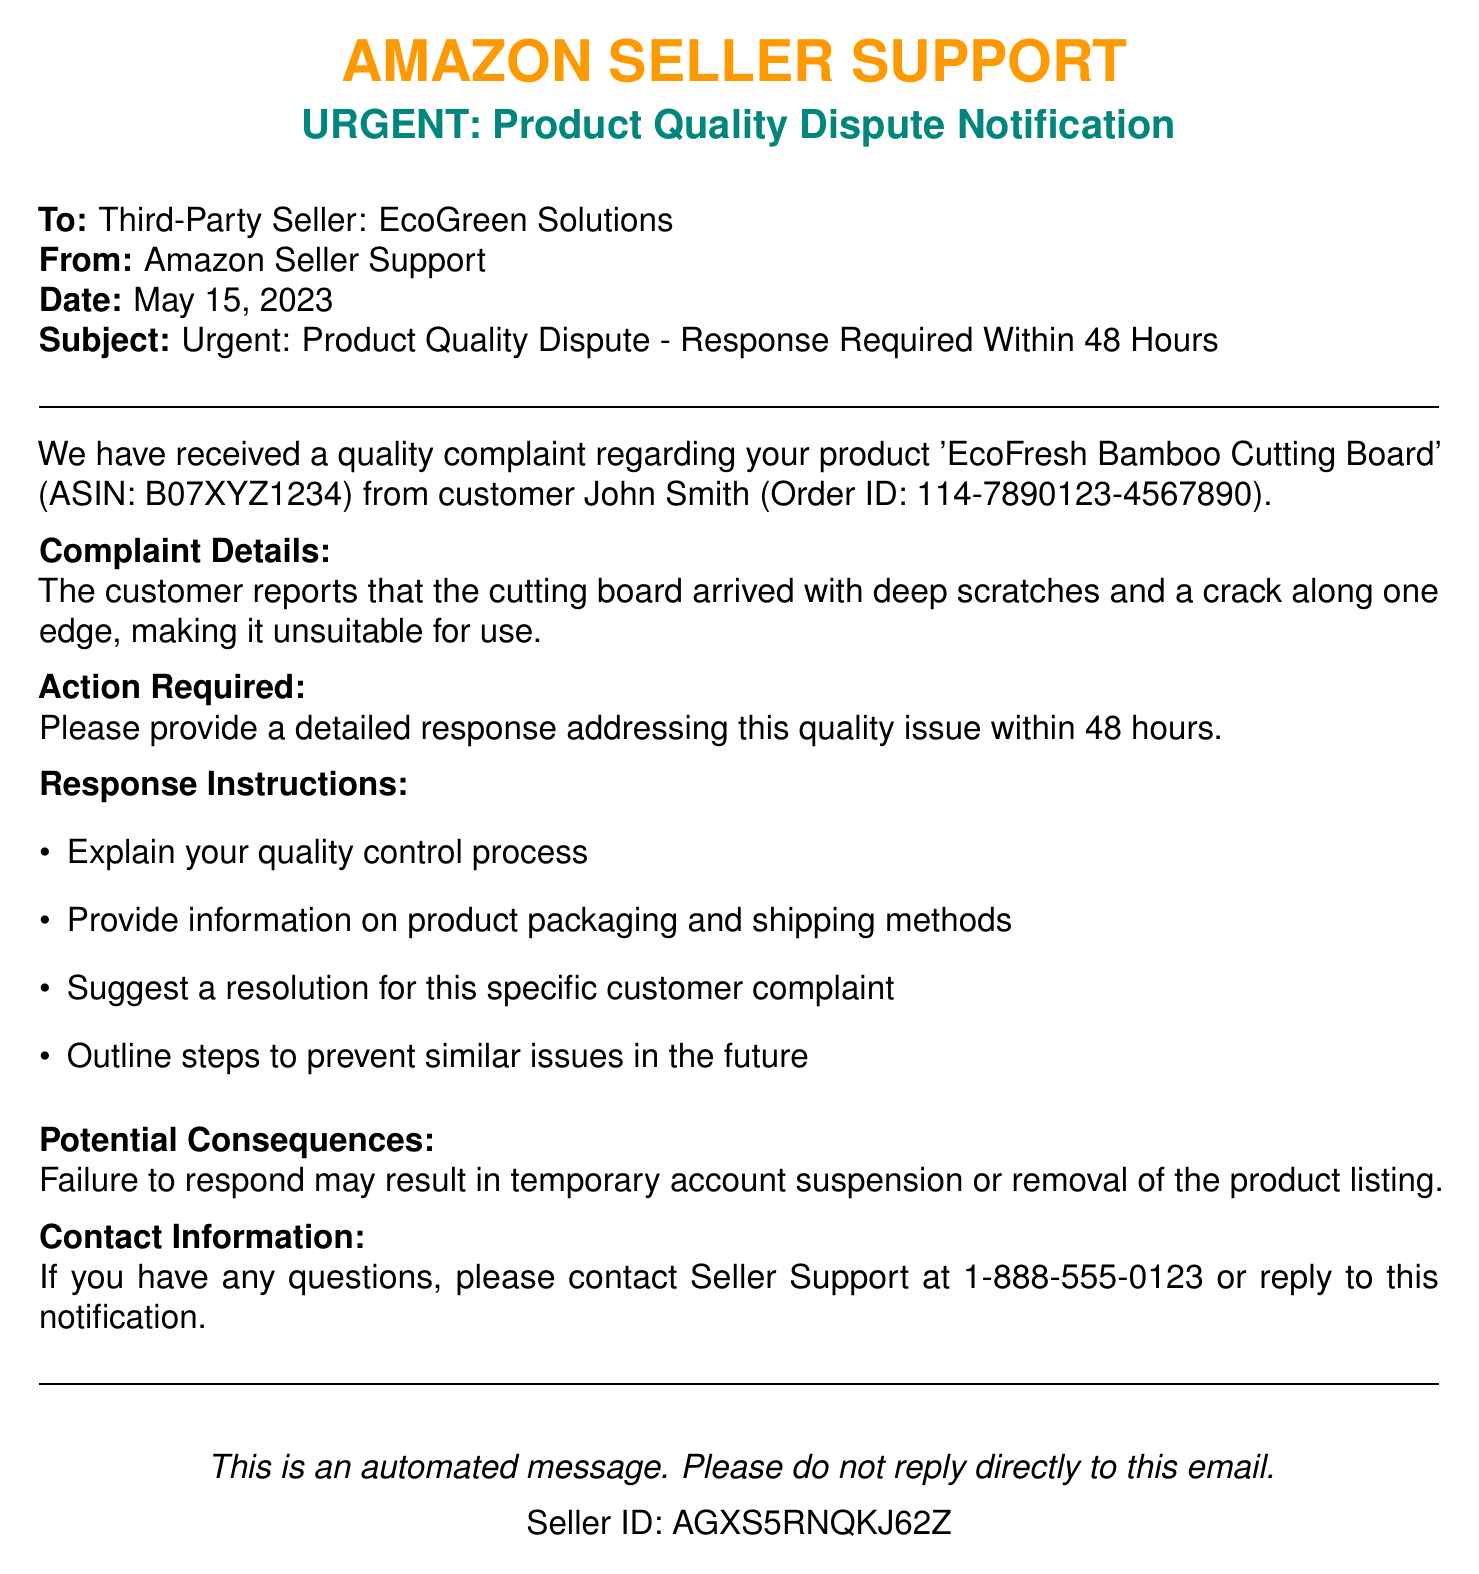What is the product name mentioned in the complaint? The document specifies 'EcoFresh Bamboo Cutting Board' as the product in the customer complaint.
Answer: EcoFresh Bamboo Cutting Board Who is the customer that filed the complaint? The document lists John Smith as the customer who made the complaint.
Answer: John Smith What is the action required from the seller? The document states that the seller must provide a detailed response addressing the quality issue.
Answer: Detailed response What is the deadline for the seller's response? The document indicates the seller must respond within 48 hours of receiving the notification.
Answer: 48 hours What are the potential consequences for failing to respond? The document warns that failure to respond may lead to temporary account suspension or removal of the product listing.
Answer: Account suspension What is the ASIN of the product in question? The document includes the ASIN B07XYZ1234 for the product related to the complaint.
Answer: B07XYZ1234 What does the customer report about the product condition? The complaint details include information about deep scratches and a crack along one edge of the cutting board.
Answer: Deep scratches and a crack What information should the seller provide regarding quality control? The seller is required to explain their quality control process in their response.
Answer: Quality control process What type of message is this document classified as? The nature of the document categorizes it as an urgent notification regarding a product quality dispute.
Answer: Urgent notification 